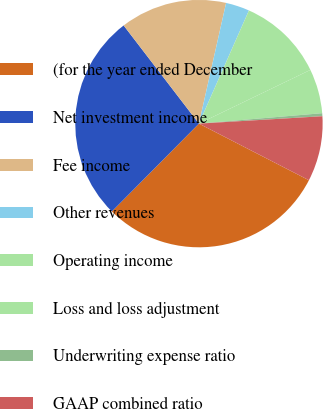Convert chart to OTSL. <chart><loc_0><loc_0><loc_500><loc_500><pie_chart><fcel>(for the year ended December<fcel>Net investment income<fcel>Fee income<fcel>Other revenues<fcel>Operating income<fcel>Loss and loss adjustment<fcel>Underwriting expense ratio<fcel>GAAP combined ratio<nl><fcel>29.87%<fcel>27.16%<fcel>13.94%<fcel>3.1%<fcel>11.23%<fcel>5.81%<fcel>0.39%<fcel>8.52%<nl></chart> 